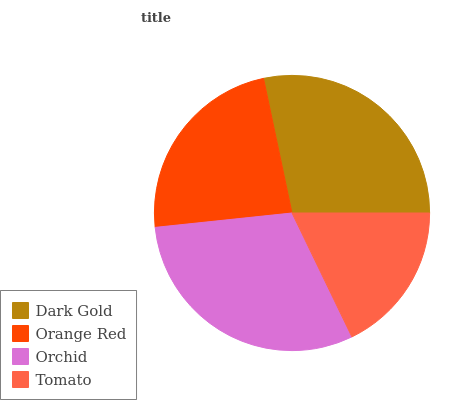Is Tomato the minimum?
Answer yes or no. Yes. Is Orchid the maximum?
Answer yes or no. Yes. Is Orange Red the minimum?
Answer yes or no. No. Is Orange Red the maximum?
Answer yes or no. No. Is Dark Gold greater than Orange Red?
Answer yes or no. Yes. Is Orange Red less than Dark Gold?
Answer yes or no. Yes. Is Orange Red greater than Dark Gold?
Answer yes or no. No. Is Dark Gold less than Orange Red?
Answer yes or no. No. Is Dark Gold the high median?
Answer yes or no. Yes. Is Orange Red the low median?
Answer yes or no. Yes. Is Orange Red the high median?
Answer yes or no. No. Is Tomato the low median?
Answer yes or no. No. 